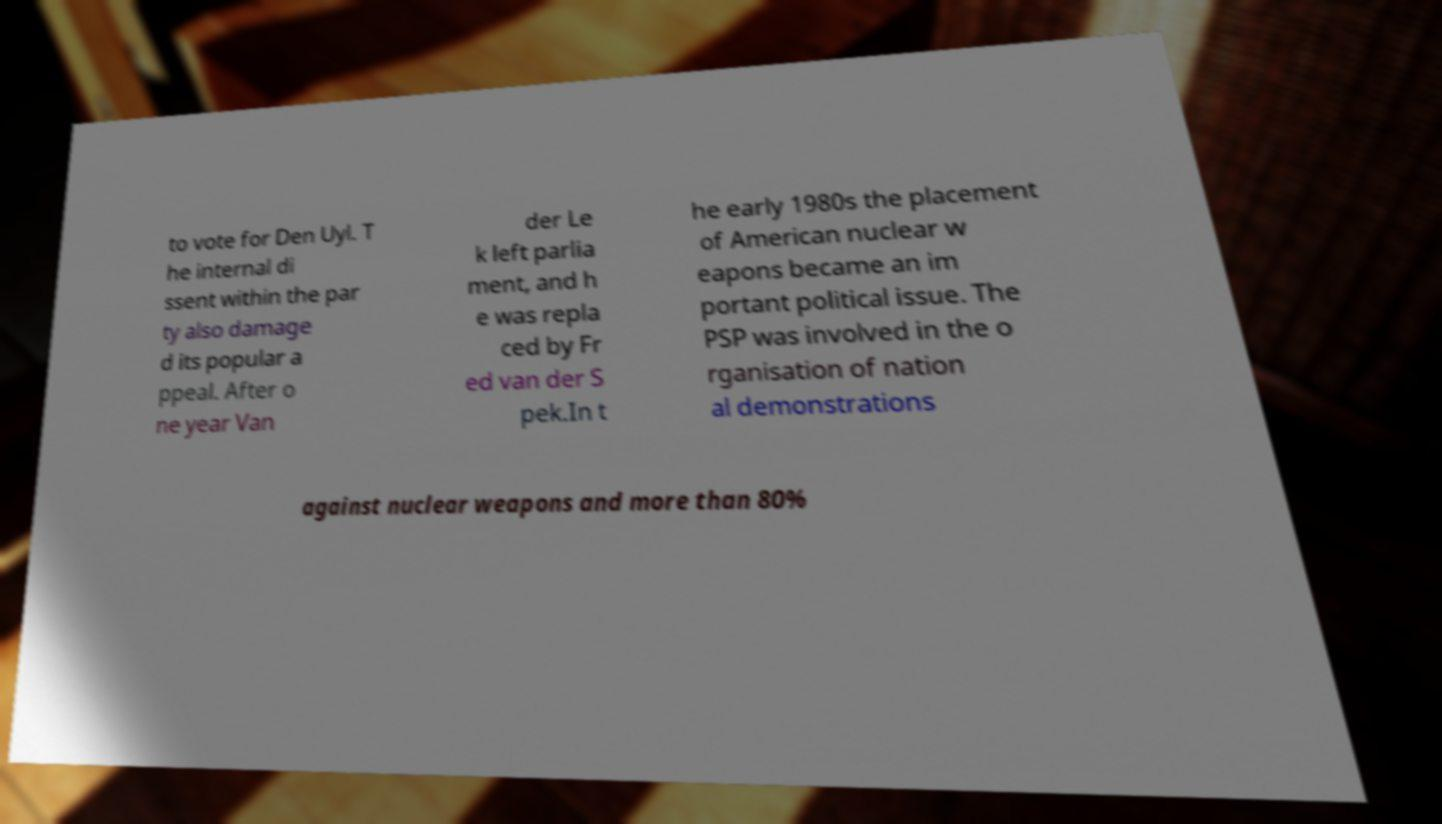What messages or text are displayed in this image? I need them in a readable, typed format. to vote for Den Uyl. T he internal di ssent within the par ty also damage d its popular a ppeal. After o ne year Van der Le k left parlia ment, and h e was repla ced by Fr ed van der S pek.In t he early 1980s the placement of American nuclear w eapons became an im portant political issue. The PSP was involved in the o rganisation of nation al demonstrations against nuclear weapons and more than 80% 